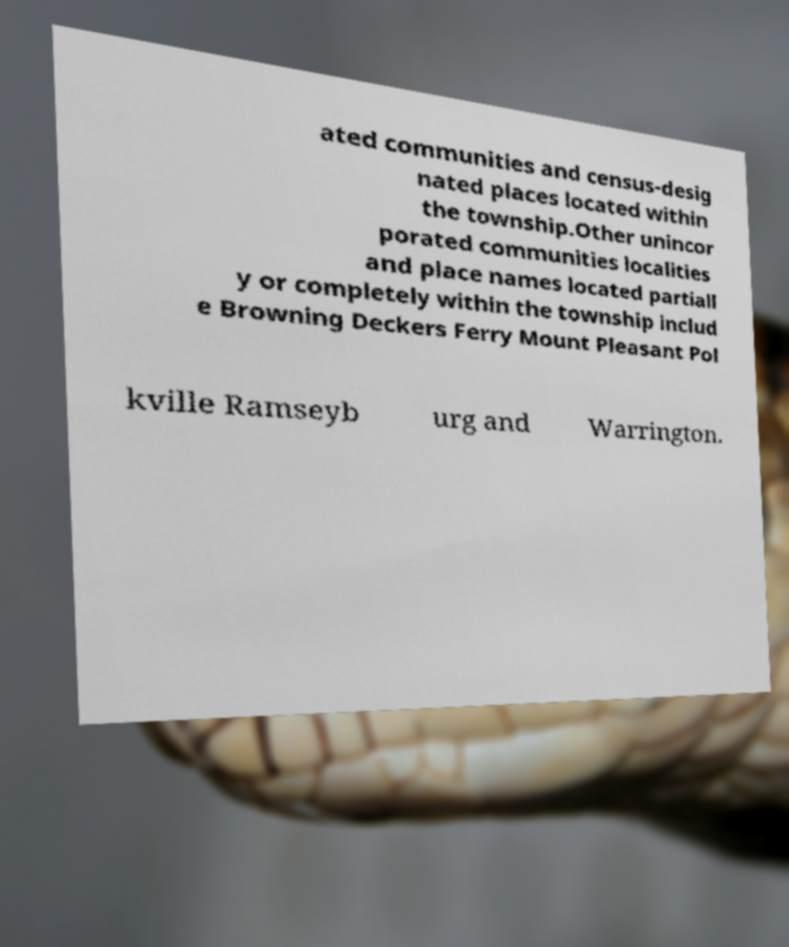Could you extract and type out the text from this image? ated communities and census-desig nated places located within the township.Other unincor porated communities localities and place names located partiall y or completely within the township includ e Browning Deckers Ferry Mount Pleasant Pol kville Ramseyb urg and Warrington. 